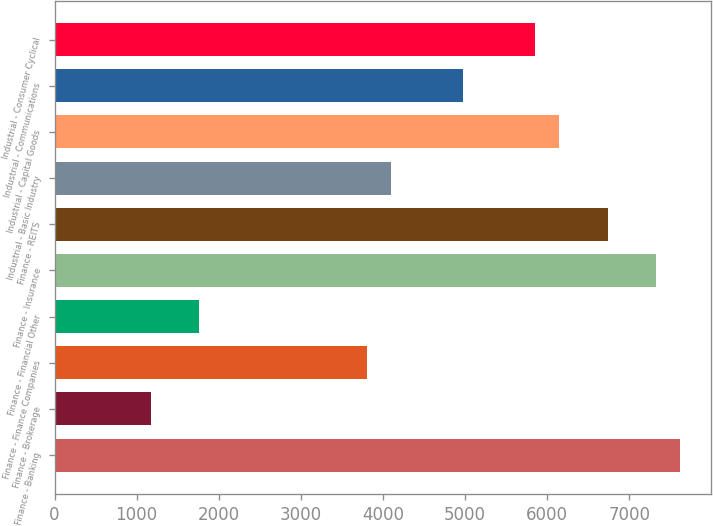<chart> <loc_0><loc_0><loc_500><loc_500><bar_chart><fcel>Finance - Banking<fcel>Finance - Brokerage<fcel>Finance - Finance Companies<fcel>Finance - Financial Other<fcel>Finance - Insurance<fcel>Finance - REITS<fcel>Industrial - Basic Industry<fcel>Industrial - Capital Goods<fcel>Industrial - Communications<fcel>Industrial - Consumer Cyclical<nl><fcel>7614.34<fcel>1171.86<fcel>3807.42<fcel>1757.54<fcel>7321.5<fcel>6735.82<fcel>4100.26<fcel>6150.14<fcel>4978.78<fcel>5857.3<nl></chart> 